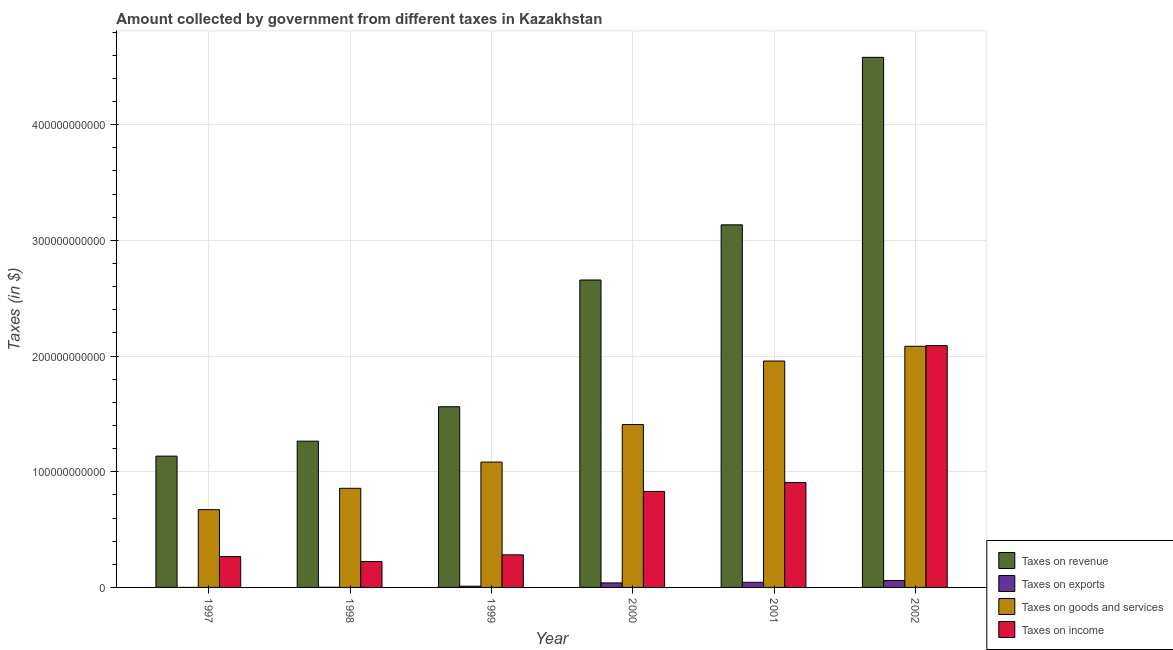How many different coloured bars are there?
Keep it short and to the point. 4. Are the number of bars per tick equal to the number of legend labels?
Ensure brevity in your answer.  Yes. How many bars are there on the 5th tick from the left?
Ensure brevity in your answer.  4. How many bars are there on the 5th tick from the right?
Your answer should be very brief. 4. What is the label of the 2nd group of bars from the left?
Ensure brevity in your answer.  1998. In how many cases, is the number of bars for a given year not equal to the number of legend labels?
Your answer should be compact. 0. What is the amount collected as tax on revenue in 1999?
Make the answer very short. 1.56e+11. Across all years, what is the maximum amount collected as tax on income?
Provide a succinct answer. 2.09e+11. Across all years, what is the minimum amount collected as tax on revenue?
Give a very brief answer. 1.13e+11. In which year was the amount collected as tax on revenue maximum?
Your response must be concise. 2002. In which year was the amount collected as tax on revenue minimum?
Provide a succinct answer. 1997. What is the total amount collected as tax on exports in the graph?
Provide a succinct answer. 1.55e+1. What is the difference between the amount collected as tax on revenue in 1997 and that in 2000?
Give a very brief answer. -1.52e+11. What is the difference between the amount collected as tax on income in 2001 and the amount collected as tax on exports in 2002?
Your answer should be very brief. -1.18e+11. What is the average amount collected as tax on income per year?
Make the answer very short. 7.66e+1. In the year 1997, what is the difference between the amount collected as tax on revenue and amount collected as tax on goods?
Keep it short and to the point. 0. In how many years, is the amount collected as tax on income greater than 300000000000 $?
Offer a very short reply. 0. What is the ratio of the amount collected as tax on goods in 1998 to that in 2000?
Provide a short and direct response. 0.61. What is the difference between the highest and the second highest amount collected as tax on revenue?
Offer a terse response. 1.45e+11. What is the difference between the highest and the lowest amount collected as tax on revenue?
Your response must be concise. 3.45e+11. Is the sum of the amount collected as tax on exports in 1998 and 2002 greater than the maximum amount collected as tax on income across all years?
Ensure brevity in your answer.  Yes. Is it the case that in every year, the sum of the amount collected as tax on exports and amount collected as tax on income is greater than the sum of amount collected as tax on goods and amount collected as tax on revenue?
Your answer should be very brief. No. What does the 1st bar from the left in 2002 represents?
Your answer should be compact. Taxes on revenue. What does the 4th bar from the right in 2002 represents?
Offer a terse response. Taxes on revenue. Is it the case that in every year, the sum of the amount collected as tax on revenue and amount collected as tax on exports is greater than the amount collected as tax on goods?
Ensure brevity in your answer.  Yes. How many bars are there?
Make the answer very short. 24. Are all the bars in the graph horizontal?
Provide a succinct answer. No. What is the difference between two consecutive major ticks on the Y-axis?
Ensure brevity in your answer.  1.00e+11. Does the graph contain any zero values?
Make the answer very short. No. Does the graph contain grids?
Give a very brief answer. Yes. Where does the legend appear in the graph?
Keep it short and to the point. Bottom right. How many legend labels are there?
Offer a very short reply. 4. What is the title of the graph?
Your answer should be very brief. Amount collected by government from different taxes in Kazakhstan. What is the label or title of the Y-axis?
Your answer should be very brief. Taxes (in $). What is the Taxes (in $) of Taxes on revenue in 1997?
Give a very brief answer. 1.13e+11. What is the Taxes (in $) in Taxes on goods and services in 1997?
Keep it short and to the point. 6.73e+1. What is the Taxes (in $) of Taxes on income in 1997?
Provide a succinct answer. 2.67e+1. What is the Taxes (in $) in Taxes on revenue in 1998?
Make the answer very short. 1.26e+11. What is the Taxes (in $) in Taxes on exports in 1998?
Give a very brief answer. 1.21e+08. What is the Taxes (in $) of Taxes on goods and services in 1998?
Your answer should be compact. 8.57e+1. What is the Taxes (in $) of Taxes on income in 1998?
Your answer should be compact. 2.24e+1. What is the Taxes (in $) of Taxes on revenue in 1999?
Provide a succinct answer. 1.56e+11. What is the Taxes (in $) in Taxes on exports in 1999?
Provide a succinct answer. 1.07e+09. What is the Taxes (in $) of Taxes on goods and services in 1999?
Your answer should be compact. 1.08e+11. What is the Taxes (in $) in Taxes on income in 1999?
Give a very brief answer. 2.82e+1. What is the Taxes (in $) of Taxes on revenue in 2000?
Give a very brief answer. 2.66e+11. What is the Taxes (in $) in Taxes on exports in 2000?
Provide a succinct answer. 3.89e+09. What is the Taxes (in $) in Taxes on goods and services in 2000?
Offer a terse response. 1.41e+11. What is the Taxes (in $) of Taxes on income in 2000?
Keep it short and to the point. 8.30e+1. What is the Taxes (in $) of Taxes on revenue in 2001?
Make the answer very short. 3.13e+11. What is the Taxes (in $) of Taxes on exports in 2001?
Make the answer very short. 4.43e+09. What is the Taxes (in $) of Taxes on goods and services in 2001?
Provide a short and direct response. 1.96e+11. What is the Taxes (in $) of Taxes on income in 2001?
Offer a terse response. 9.07e+1. What is the Taxes (in $) of Taxes on revenue in 2002?
Make the answer very short. 4.58e+11. What is the Taxes (in $) of Taxes on exports in 2002?
Your response must be concise. 5.97e+09. What is the Taxes (in $) in Taxes on goods and services in 2002?
Ensure brevity in your answer.  2.08e+11. What is the Taxes (in $) in Taxes on income in 2002?
Offer a very short reply. 2.09e+11. Across all years, what is the maximum Taxes (in $) of Taxes on revenue?
Your response must be concise. 4.58e+11. Across all years, what is the maximum Taxes (in $) in Taxes on exports?
Ensure brevity in your answer.  5.97e+09. Across all years, what is the maximum Taxes (in $) in Taxes on goods and services?
Your answer should be very brief. 2.08e+11. Across all years, what is the maximum Taxes (in $) of Taxes on income?
Your answer should be compact. 2.09e+11. Across all years, what is the minimum Taxes (in $) of Taxes on revenue?
Provide a succinct answer. 1.13e+11. Across all years, what is the minimum Taxes (in $) in Taxes on goods and services?
Offer a terse response. 6.73e+1. Across all years, what is the minimum Taxes (in $) in Taxes on income?
Ensure brevity in your answer.  2.24e+1. What is the total Taxes (in $) in Taxes on revenue in the graph?
Your answer should be very brief. 1.43e+12. What is the total Taxes (in $) of Taxes on exports in the graph?
Ensure brevity in your answer.  1.55e+1. What is the total Taxes (in $) of Taxes on goods and services in the graph?
Ensure brevity in your answer.  8.06e+11. What is the total Taxes (in $) in Taxes on income in the graph?
Provide a succinct answer. 4.60e+11. What is the difference between the Taxes (in $) in Taxes on revenue in 1997 and that in 1998?
Your response must be concise. -1.29e+1. What is the difference between the Taxes (in $) of Taxes on exports in 1997 and that in 1998?
Make the answer very short. -1.19e+08. What is the difference between the Taxes (in $) in Taxes on goods and services in 1997 and that in 1998?
Your answer should be very brief. -1.84e+1. What is the difference between the Taxes (in $) of Taxes on income in 1997 and that in 1998?
Your answer should be compact. 4.28e+09. What is the difference between the Taxes (in $) of Taxes on revenue in 1997 and that in 1999?
Keep it short and to the point. -4.27e+1. What is the difference between the Taxes (in $) of Taxes on exports in 1997 and that in 1999?
Your answer should be compact. -1.07e+09. What is the difference between the Taxes (in $) in Taxes on goods and services in 1997 and that in 1999?
Provide a short and direct response. -4.11e+1. What is the difference between the Taxes (in $) of Taxes on income in 1997 and that in 1999?
Give a very brief answer. -1.53e+09. What is the difference between the Taxes (in $) of Taxes on revenue in 1997 and that in 2000?
Offer a very short reply. -1.52e+11. What is the difference between the Taxes (in $) of Taxes on exports in 1997 and that in 2000?
Give a very brief answer. -3.88e+09. What is the difference between the Taxes (in $) of Taxes on goods and services in 1997 and that in 2000?
Keep it short and to the point. -7.35e+1. What is the difference between the Taxes (in $) of Taxes on income in 1997 and that in 2000?
Your response must be concise. -5.63e+1. What is the difference between the Taxes (in $) of Taxes on revenue in 1997 and that in 2001?
Your answer should be very brief. -2.00e+11. What is the difference between the Taxes (in $) in Taxes on exports in 1997 and that in 2001?
Your answer should be very brief. -4.43e+09. What is the difference between the Taxes (in $) of Taxes on goods and services in 1997 and that in 2001?
Keep it short and to the point. -1.28e+11. What is the difference between the Taxes (in $) in Taxes on income in 1997 and that in 2001?
Keep it short and to the point. -6.40e+1. What is the difference between the Taxes (in $) in Taxes on revenue in 1997 and that in 2002?
Offer a terse response. -3.45e+11. What is the difference between the Taxes (in $) of Taxes on exports in 1997 and that in 2002?
Provide a succinct answer. -5.96e+09. What is the difference between the Taxes (in $) of Taxes on goods and services in 1997 and that in 2002?
Make the answer very short. -1.41e+11. What is the difference between the Taxes (in $) of Taxes on income in 1997 and that in 2002?
Ensure brevity in your answer.  -1.82e+11. What is the difference between the Taxes (in $) of Taxes on revenue in 1998 and that in 1999?
Offer a terse response. -2.97e+1. What is the difference between the Taxes (in $) of Taxes on exports in 1998 and that in 1999?
Offer a terse response. -9.53e+08. What is the difference between the Taxes (in $) in Taxes on goods and services in 1998 and that in 1999?
Keep it short and to the point. -2.27e+1. What is the difference between the Taxes (in $) of Taxes on income in 1998 and that in 1999?
Keep it short and to the point. -5.81e+09. What is the difference between the Taxes (in $) of Taxes on revenue in 1998 and that in 2000?
Provide a short and direct response. -1.39e+11. What is the difference between the Taxes (in $) of Taxes on exports in 1998 and that in 2000?
Make the answer very short. -3.76e+09. What is the difference between the Taxes (in $) of Taxes on goods and services in 1998 and that in 2000?
Your answer should be very brief. -5.51e+1. What is the difference between the Taxes (in $) of Taxes on income in 1998 and that in 2000?
Offer a very short reply. -6.06e+1. What is the difference between the Taxes (in $) of Taxes on revenue in 1998 and that in 2001?
Keep it short and to the point. -1.87e+11. What is the difference between the Taxes (in $) in Taxes on exports in 1998 and that in 2001?
Make the answer very short. -4.31e+09. What is the difference between the Taxes (in $) of Taxes on goods and services in 1998 and that in 2001?
Keep it short and to the point. -1.10e+11. What is the difference between the Taxes (in $) in Taxes on income in 1998 and that in 2001?
Ensure brevity in your answer.  -6.83e+1. What is the difference between the Taxes (in $) in Taxes on revenue in 1998 and that in 2002?
Provide a succinct answer. -3.32e+11. What is the difference between the Taxes (in $) in Taxes on exports in 1998 and that in 2002?
Offer a very short reply. -5.85e+09. What is the difference between the Taxes (in $) of Taxes on goods and services in 1998 and that in 2002?
Your response must be concise. -1.23e+11. What is the difference between the Taxes (in $) in Taxes on income in 1998 and that in 2002?
Provide a short and direct response. -1.87e+11. What is the difference between the Taxes (in $) in Taxes on revenue in 1999 and that in 2000?
Offer a terse response. -1.10e+11. What is the difference between the Taxes (in $) of Taxes on exports in 1999 and that in 2000?
Your answer should be compact. -2.81e+09. What is the difference between the Taxes (in $) in Taxes on goods and services in 1999 and that in 2000?
Offer a terse response. -3.24e+1. What is the difference between the Taxes (in $) in Taxes on income in 1999 and that in 2000?
Provide a succinct answer. -5.48e+1. What is the difference between the Taxes (in $) of Taxes on revenue in 1999 and that in 2001?
Make the answer very short. -1.57e+11. What is the difference between the Taxes (in $) in Taxes on exports in 1999 and that in 2001?
Your answer should be very brief. -3.36e+09. What is the difference between the Taxes (in $) in Taxes on goods and services in 1999 and that in 2001?
Your response must be concise. -8.74e+1. What is the difference between the Taxes (in $) of Taxes on income in 1999 and that in 2001?
Provide a short and direct response. -6.25e+1. What is the difference between the Taxes (in $) of Taxes on revenue in 1999 and that in 2002?
Your response must be concise. -3.02e+11. What is the difference between the Taxes (in $) in Taxes on exports in 1999 and that in 2002?
Ensure brevity in your answer.  -4.89e+09. What is the difference between the Taxes (in $) of Taxes on goods and services in 1999 and that in 2002?
Make the answer very short. -1.00e+11. What is the difference between the Taxes (in $) of Taxes on income in 1999 and that in 2002?
Keep it short and to the point. -1.81e+11. What is the difference between the Taxes (in $) of Taxes on revenue in 2000 and that in 2001?
Offer a very short reply. -4.77e+1. What is the difference between the Taxes (in $) of Taxes on exports in 2000 and that in 2001?
Your response must be concise. -5.48e+08. What is the difference between the Taxes (in $) in Taxes on goods and services in 2000 and that in 2001?
Provide a short and direct response. -5.49e+1. What is the difference between the Taxes (in $) of Taxes on income in 2000 and that in 2001?
Provide a short and direct response. -7.72e+09. What is the difference between the Taxes (in $) in Taxes on revenue in 2000 and that in 2002?
Keep it short and to the point. -1.92e+11. What is the difference between the Taxes (in $) of Taxes on exports in 2000 and that in 2002?
Make the answer very short. -2.08e+09. What is the difference between the Taxes (in $) in Taxes on goods and services in 2000 and that in 2002?
Offer a very short reply. -6.77e+1. What is the difference between the Taxes (in $) in Taxes on income in 2000 and that in 2002?
Your answer should be very brief. -1.26e+11. What is the difference between the Taxes (in $) in Taxes on revenue in 2001 and that in 2002?
Provide a succinct answer. -1.45e+11. What is the difference between the Taxes (in $) of Taxes on exports in 2001 and that in 2002?
Offer a very short reply. -1.53e+09. What is the difference between the Taxes (in $) in Taxes on goods and services in 2001 and that in 2002?
Ensure brevity in your answer.  -1.27e+1. What is the difference between the Taxes (in $) in Taxes on income in 2001 and that in 2002?
Ensure brevity in your answer.  -1.18e+11. What is the difference between the Taxes (in $) in Taxes on revenue in 1997 and the Taxes (in $) in Taxes on exports in 1998?
Offer a very short reply. 1.13e+11. What is the difference between the Taxes (in $) in Taxes on revenue in 1997 and the Taxes (in $) in Taxes on goods and services in 1998?
Provide a succinct answer. 2.78e+1. What is the difference between the Taxes (in $) of Taxes on revenue in 1997 and the Taxes (in $) of Taxes on income in 1998?
Ensure brevity in your answer.  9.11e+1. What is the difference between the Taxes (in $) of Taxes on exports in 1997 and the Taxes (in $) of Taxes on goods and services in 1998?
Provide a short and direct response. -8.57e+1. What is the difference between the Taxes (in $) of Taxes on exports in 1997 and the Taxes (in $) of Taxes on income in 1998?
Keep it short and to the point. -2.24e+1. What is the difference between the Taxes (in $) in Taxes on goods and services in 1997 and the Taxes (in $) in Taxes on income in 1998?
Your answer should be compact. 4.49e+1. What is the difference between the Taxes (in $) in Taxes on revenue in 1997 and the Taxes (in $) in Taxes on exports in 1999?
Your answer should be compact. 1.12e+11. What is the difference between the Taxes (in $) in Taxes on revenue in 1997 and the Taxes (in $) in Taxes on goods and services in 1999?
Your response must be concise. 5.15e+09. What is the difference between the Taxes (in $) in Taxes on revenue in 1997 and the Taxes (in $) in Taxes on income in 1999?
Keep it short and to the point. 8.53e+1. What is the difference between the Taxes (in $) of Taxes on exports in 1997 and the Taxes (in $) of Taxes on goods and services in 1999?
Provide a short and direct response. -1.08e+11. What is the difference between the Taxes (in $) in Taxes on exports in 1997 and the Taxes (in $) in Taxes on income in 1999?
Ensure brevity in your answer.  -2.82e+1. What is the difference between the Taxes (in $) of Taxes on goods and services in 1997 and the Taxes (in $) of Taxes on income in 1999?
Your response must be concise. 3.91e+1. What is the difference between the Taxes (in $) in Taxes on revenue in 1997 and the Taxes (in $) in Taxes on exports in 2000?
Offer a very short reply. 1.10e+11. What is the difference between the Taxes (in $) in Taxes on revenue in 1997 and the Taxes (in $) in Taxes on goods and services in 2000?
Your response must be concise. -2.73e+1. What is the difference between the Taxes (in $) in Taxes on revenue in 1997 and the Taxes (in $) in Taxes on income in 2000?
Provide a short and direct response. 3.05e+1. What is the difference between the Taxes (in $) in Taxes on exports in 1997 and the Taxes (in $) in Taxes on goods and services in 2000?
Keep it short and to the point. -1.41e+11. What is the difference between the Taxes (in $) in Taxes on exports in 1997 and the Taxes (in $) in Taxes on income in 2000?
Ensure brevity in your answer.  -8.30e+1. What is the difference between the Taxes (in $) in Taxes on goods and services in 1997 and the Taxes (in $) in Taxes on income in 2000?
Your answer should be compact. -1.57e+1. What is the difference between the Taxes (in $) in Taxes on revenue in 1997 and the Taxes (in $) in Taxes on exports in 2001?
Keep it short and to the point. 1.09e+11. What is the difference between the Taxes (in $) of Taxes on revenue in 1997 and the Taxes (in $) of Taxes on goods and services in 2001?
Your response must be concise. -8.22e+1. What is the difference between the Taxes (in $) in Taxes on revenue in 1997 and the Taxes (in $) in Taxes on income in 2001?
Your answer should be compact. 2.28e+1. What is the difference between the Taxes (in $) of Taxes on exports in 1997 and the Taxes (in $) of Taxes on goods and services in 2001?
Ensure brevity in your answer.  -1.96e+11. What is the difference between the Taxes (in $) in Taxes on exports in 1997 and the Taxes (in $) in Taxes on income in 2001?
Give a very brief answer. -9.07e+1. What is the difference between the Taxes (in $) in Taxes on goods and services in 1997 and the Taxes (in $) in Taxes on income in 2001?
Your response must be concise. -2.34e+1. What is the difference between the Taxes (in $) in Taxes on revenue in 1997 and the Taxes (in $) in Taxes on exports in 2002?
Your answer should be very brief. 1.08e+11. What is the difference between the Taxes (in $) of Taxes on revenue in 1997 and the Taxes (in $) of Taxes on goods and services in 2002?
Make the answer very short. -9.50e+1. What is the difference between the Taxes (in $) in Taxes on revenue in 1997 and the Taxes (in $) in Taxes on income in 2002?
Offer a terse response. -9.56e+1. What is the difference between the Taxes (in $) of Taxes on exports in 1997 and the Taxes (in $) of Taxes on goods and services in 2002?
Keep it short and to the point. -2.08e+11. What is the difference between the Taxes (in $) in Taxes on exports in 1997 and the Taxes (in $) in Taxes on income in 2002?
Offer a very short reply. -2.09e+11. What is the difference between the Taxes (in $) of Taxes on goods and services in 1997 and the Taxes (in $) of Taxes on income in 2002?
Offer a very short reply. -1.42e+11. What is the difference between the Taxes (in $) in Taxes on revenue in 1998 and the Taxes (in $) in Taxes on exports in 1999?
Offer a very short reply. 1.25e+11. What is the difference between the Taxes (in $) of Taxes on revenue in 1998 and the Taxes (in $) of Taxes on goods and services in 1999?
Provide a succinct answer. 1.81e+1. What is the difference between the Taxes (in $) of Taxes on revenue in 1998 and the Taxes (in $) of Taxes on income in 1999?
Give a very brief answer. 9.83e+1. What is the difference between the Taxes (in $) in Taxes on exports in 1998 and the Taxes (in $) in Taxes on goods and services in 1999?
Make the answer very short. -1.08e+11. What is the difference between the Taxes (in $) in Taxes on exports in 1998 and the Taxes (in $) in Taxes on income in 1999?
Give a very brief answer. -2.81e+1. What is the difference between the Taxes (in $) of Taxes on goods and services in 1998 and the Taxes (in $) of Taxes on income in 1999?
Provide a short and direct response. 5.75e+1. What is the difference between the Taxes (in $) in Taxes on revenue in 1998 and the Taxes (in $) in Taxes on exports in 2000?
Make the answer very short. 1.23e+11. What is the difference between the Taxes (in $) of Taxes on revenue in 1998 and the Taxes (in $) of Taxes on goods and services in 2000?
Make the answer very short. -1.43e+1. What is the difference between the Taxes (in $) of Taxes on revenue in 1998 and the Taxes (in $) of Taxes on income in 2000?
Your answer should be compact. 4.35e+1. What is the difference between the Taxes (in $) in Taxes on exports in 1998 and the Taxes (in $) in Taxes on goods and services in 2000?
Keep it short and to the point. -1.41e+11. What is the difference between the Taxes (in $) in Taxes on exports in 1998 and the Taxes (in $) in Taxes on income in 2000?
Your answer should be compact. -8.28e+1. What is the difference between the Taxes (in $) in Taxes on goods and services in 1998 and the Taxes (in $) in Taxes on income in 2000?
Your response must be concise. 2.72e+09. What is the difference between the Taxes (in $) of Taxes on revenue in 1998 and the Taxes (in $) of Taxes on exports in 2001?
Give a very brief answer. 1.22e+11. What is the difference between the Taxes (in $) of Taxes on revenue in 1998 and the Taxes (in $) of Taxes on goods and services in 2001?
Your answer should be compact. -6.93e+1. What is the difference between the Taxes (in $) in Taxes on revenue in 1998 and the Taxes (in $) in Taxes on income in 2001?
Your answer should be compact. 3.58e+1. What is the difference between the Taxes (in $) in Taxes on exports in 1998 and the Taxes (in $) in Taxes on goods and services in 2001?
Provide a short and direct response. -1.96e+11. What is the difference between the Taxes (in $) of Taxes on exports in 1998 and the Taxes (in $) of Taxes on income in 2001?
Offer a very short reply. -9.06e+1. What is the difference between the Taxes (in $) in Taxes on goods and services in 1998 and the Taxes (in $) in Taxes on income in 2001?
Provide a succinct answer. -4.99e+09. What is the difference between the Taxes (in $) of Taxes on revenue in 1998 and the Taxes (in $) of Taxes on exports in 2002?
Offer a terse response. 1.20e+11. What is the difference between the Taxes (in $) in Taxes on revenue in 1998 and the Taxes (in $) in Taxes on goods and services in 2002?
Give a very brief answer. -8.20e+1. What is the difference between the Taxes (in $) of Taxes on revenue in 1998 and the Taxes (in $) of Taxes on income in 2002?
Your answer should be compact. -8.26e+1. What is the difference between the Taxes (in $) in Taxes on exports in 1998 and the Taxes (in $) in Taxes on goods and services in 2002?
Provide a succinct answer. -2.08e+11. What is the difference between the Taxes (in $) of Taxes on exports in 1998 and the Taxes (in $) of Taxes on income in 2002?
Provide a succinct answer. -2.09e+11. What is the difference between the Taxes (in $) in Taxes on goods and services in 1998 and the Taxes (in $) in Taxes on income in 2002?
Your response must be concise. -1.23e+11. What is the difference between the Taxes (in $) in Taxes on revenue in 1999 and the Taxes (in $) in Taxes on exports in 2000?
Provide a succinct answer. 1.52e+11. What is the difference between the Taxes (in $) in Taxes on revenue in 1999 and the Taxes (in $) in Taxes on goods and services in 2000?
Offer a very short reply. 1.54e+1. What is the difference between the Taxes (in $) of Taxes on revenue in 1999 and the Taxes (in $) of Taxes on income in 2000?
Your response must be concise. 7.32e+1. What is the difference between the Taxes (in $) of Taxes on exports in 1999 and the Taxes (in $) of Taxes on goods and services in 2000?
Your answer should be very brief. -1.40e+11. What is the difference between the Taxes (in $) of Taxes on exports in 1999 and the Taxes (in $) of Taxes on income in 2000?
Provide a short and direct response. -8.19e+1. What is the difference between the Taxes (in $) of Taxes on goods and services in 1999 and the Taxes (in $) of Taxes on income in 2000?
Offer a very short reply. 2.54e+1. What is the difference between the Taxes (in $) of Taxes on revenue in 1999 and the Taxes (in $) of Taxes on exports in 2001?
Your response must be concise. 1.52e+11. What is the difference between the Taxes (in $) of Taxes on revenue in 1999 and the Taxes (in $) of Taxes on goods and services in 2001?
Your answer should be compact. -3.95e+1. What is the difference between the Taxes (in $) of Taxes on revenue in 1999 and the Taxes (in $) of Taxes on income in 2001?
Give a very brief answer. 6.55e+1. What is the difference between the Taxes (in $) of Taxes on exports in 1999 and the Taxes (in $) of Taxes on goods and services in 2001?
Keep it short and to the point. -1.95e+11. What is the difference between the Taxes (in $) in Taxes on exports in 1999 and the Taxes (in $) in Taxes on income in 2001?
Your answer should be very brief. -8.96e+1. What is the difference between the Taxes (in $) of Taxes on goods and services in 1999 and the Taxes (in $) of Taxes on income in 2001?
Keep it short and to the point. 1.77e+1. What is the difference between the Taxes (in $) of Taxes on revenue in 1999 and the Taxes (in $) of Taxes on exports in 2002?
Make the answer very short. 1.50e+11. What is the difference between the Taxes (in $) of Taxes on revenue in 1999 and the Taxes (in $) of Taxes on goods and services in 2002?
Provide a short and direct response. -5.23e+1. What is the difference between the Taxes (in $) of Taxes on revenue in 1999 and the Taxes (in $) of Taxes on income in 2002?
Offer a terse response. -5.29e+1. What is the difference between the Taxes (in $) of Taxes on exports in 1999 and the Taxes (in $) of Taxes on goods and services in 2002?
Keep it short and to the point. -2.07e+11. What is the difference between the Taxes (in $) of Taxes on exports in 1999 and the Taxes (in $) of Taxes on income in 2002?
Offer a very short reply. -2.08e+11. What is the difference between the Taxes (in $) in Taxes on goods and services in 1999 and the Taxes (in $) in Taxes on income in 2002?
Offer a terse response. -1.01e+11. What is the difference between the Taxes (in $) of Taxes on revenue in 2000 and the Taxes (in $) of Taxes on exports in 2001?
Your response must be concise. 2.61e+11. What is the difference between the Taxes (in $) of Taxes on revenue in 2000 and the Taxes (in $) of Taxes on goods and services in 2001?
Make the answer very short. 7.00e+1. What is the difference between the Taxes (in $) in Taxes on revenue in 2000 and the Taxes (in $) in Taxes on income in 2001?
Ensure brevity in your answer.  1.75e+11. What is the difference between the Taxes (in $) of Taxes on exports in 2000 and the Taxes (in $) of Taxes on goods and services in 2001?
Offer a terse response. -1.92e+11. What is the difference between the Taxes (in $) of Taxes on exports in 2000 and the Taxes (in $) of Taxes on income in 2001?
Offer a terse response. -8.68e+1. What is the difference between the Taxes (in $) in Taxes on goods and services in 2000 and the Taxes (in $) in Taxes on income in 2001?
Offer a terse response. 5.01e+1. What is the difference between the Taxes (in $) in Taxes on revenue in 2000 and the Taxes (in $) in Taxes on exports in 2002?
Provide a succinct answer. 2.60e+11. What is the difference between the Taxes (in $) of Taxes on revenue in 2000 and the Taxes (in $) of Taxes on goods and services in 2002?
Offer a terse response. 5.73e+1. What is the difference between the Taxes (in $) in Taxes on revenue in 2000 and the Taxes (in $) in Taxes on income in 2002?
Provide a short and direct response. 5.67e+1. What is the difference between the Taxes (in $) in Taxes on exports in 2000 and the Taxes (in $) in Taxes on goods and services in 2002?
Ensure brevity in your answer.  -2.05e+11. What is the difference between the Taxes (in $) in Taxes on exports in 2000 and the Taxes (in $) in Taxes on income in 2002?
Your answer should be compact. -2.05e+11. What is the difference between the Taxes (in $) in Taxes on goods and services in 2000 and the Taxes (in $) in Taxes on income in 2002?
Provide a short and direct response. -6.83e+1. What is the difference between the Taxes (in $) of Taxes on revenue in 2001 and the Taxes (in $) of Taxes on exports in 2002?
Provide a short and direct response. 3.07e+11. What is the difference between the Taxes (in $) in Taxes on revenue in 2001 and the Taxes (in $) in Taxes on goods and services in 2002?
Keep it short and to the point. 1.05e+11. What is the difference between the Taxes (in $) of Taxes on revenue in 2001 and the Taxes (in $) of Taxes on income in 2002?
Your answer should be very brief. 1.04e+11. What is the difference between the Taxes (in $) of Taxes on exports in 2001 and the Taxes (in $) of Taxes on goods and services in 2002?
Offer a very short reply. -2.04e+11. What is the difference between the Taxes (in $) of Taxes on exports in 2001 and the Taxes (in $) of Taxes on income in 2002?
Give a very brief answer. -2.05e+11. What is the difference between the Taxes (in $) of Taxes on goods and services in 2001 and the Taxes (in $) of Taxes on income in 2002?
Offer a very short reply. -1.33e+1. What is the average Taxes (in $) of Taxes on revenue per year?
Ensure brevity in your answer.  2.39e+11. What is the average Taxes (in $) of Taxes on exports per year?
Your response must be concise. 2.58e+09. What is the average Taxes (in $) of Taxes on goods and services per year?
Provide a short and direct response. 1.34e+11. What is the average Taxes (in $) in Taxes on income per year?
Make the answer very short. 7.66e+1. In the year 1997, what is the difference between the Taxes (in $) in Taxes on revenue and Taxes (in $) in Taxes on exports?
Your answer should be very brief. 1.13e+11. In the year 1997, what is the difference between the Taxes (in $) in Taxes on revenue and Taxes (in $) in Taxes on goods and services?
Provide a succinct answer. 4.62e+1. In the year 1997, what is the difference between the Taxes (in $) in Taxes on revenue and Taxes (in $) in Taxes on income?
Provide a succinct answer. 8.68e+1. In the year 1997, what is the difference between the Taxes (in $) of Taxes on exports and Taxes (in $) of Taxes on goods and services?
Your answer should be very brief. -6.72e+1. In the year 1997, what is the difference between the Taxes (in $) in Taxes on exports and Taxes (in $) in Taxes on income?
Your answer should be very brief. -2.66e+1. In the year 1997, what is the difference between the Taxes (in $) of Taxes on goods and services and Taxes (in $) of Taxes on income?
Your answer should be very brief. 4.06e+1. In the year 1998, what is the difference between the Taxes (in $) of Taxes on revenue and Taxes (in $) of Taxes on exports?
Keep it short and to the point. 1.26e+11. In the year 1998, what is the difference between the Taxes (in $) of Taxes on revenue and Taxes (in $) of Taxes on goods and services?
Provide a succinct answer. 4.08e+1. In the year 1998, what is the difference between the Taxes (in $) of Taxes on revenue and Taxes (in $) of Taxes on income?
Your answer should be compact. 1.04e+11. In the year 1998, what is the difference between the Taxes (in $) in Taxes on exports and Taxes (in $) in Taxes on goods and services?
Ensure brevity in your answer.  -8.56e+1. In the year 1998, what is the difference between the Taxes (in $) in Taxes on exports and Taxes (in $) in Taxes on income?
Provide a succinct answer. -2.22e+1. In the year 1998, what is the difference between the Taxes (in $) in Taxes on goods and services and Taxes (in $) in Taxes on income?
Your answer should be very brief. 6.33e+1. In the year 1999, what is the difference between the Taxes (in $) in Taxes on revenue and Taxes (in $) in Taxes on exports?
Make the answer very short. 1.55e+11. In the year 1999, what is the difference between the Taxes (in $) of Taxes on revenue and Taxes (in $) of Taxes on goods and services?
Your answer should be compact. 4.78e+1. In the year 1999, what is the difference between the Taxes (in $) in Taxes on revenue and Taxes (in $) in Taxes on income?
Provide a short and direct response. 1.28e+11. In the year 1999, what is the difference between the Taxes (in $) in Taxes on exports and Taxes (in $) in Taxes on goods and services?
Keep it short and to the point. -1.07e+11. In the year 1999, what is the difference between the Taxes (in $) in Taxes on exports and Taxes (in $) in Taxes on income?
Provide a succinct answer. -2.71e+1. In the year 1999, what is the difference between the Taxes (in $) of Taxes on goods and services and Taxes (in $) of Taxes on income?
Offer a terse response. 8.02e+1. In the year 2000, what is the difference between the Taxes (in $) of Taxes on revenue and Taxes (in $) of Taxes on exports?
Offer a very short reply. 2.62e+11. In the year 2000, what is the difference between the Taxes (in $) in Taxes on revenue and Taxes (in $) in Taxes on goods and services?
Your answer should be very brief. 1.25e+11. In the year 2000, what is the difference between the Taxes (in $) in Taxes on revenue and Taxes (in $) in Taxes on income?
Your answer should be very brief. 1.83e+11. In the year 2000, what is the difference between the Taxes (in $) in Taxes on exports and Taxes (in $) in Taxes on goods and services?
Ensure brevity in your answer.  -1.37e+11. In the year 2000, what is the difference between the Taxes (in $) of Taxes on exports and Taxes (in $) of Taxes on income?
Offer a terse response. -7.91e+1. In the year 2000, what is the difference between the Taxes (in $) in Taxes on goods and services and Taxes (in $) in Taxes on income?
Your response must be concise. 5.78e+1. In the year 2001, what is the difference between the Taxes (in $) of Taxes on revenue and Taxes (in $) of Taxes on exports?
Give a very brief answer. 3.09e+11. In the year 2001, what is the difference between the Taxes (in $) in Taxes on revenue and Taxes (in $) in Taxes on goods and services?
Make the answer very short. 1.18e+11. In the year 2001, what is the difference between the Taxes (in $) of Taxes on revenue and Taxes (in $) of Taxes on income?
Offer a very short reply. 2.23e+11. In the year 2001, what is the difference between the Taxes (in $) of Taxes on exports and Taxes (in $) of Taxes on goods and services?
Your answer should be very brief. -1.91e+11. In the year 2001, what is the difference between the Taxes (in $) of Taxes on exports and Taxes (in $) of Taxes on income?
Offer a terse response. -8.62e+1. In the year 2001, what is the difference between the Taxes (in $) of Taxes on goods and services and Taxes (in $) of Taxes on income?
Provide a succinct answer. 1.05e+11. In the year 2002, what is the difference between the Taxes (in $) in Taxes on revenue and Taxes (in $) in Taxes on exports?
Your answer should be very brief. 4.52e+11. In the year 2002, what is the difference between the Taxes (in $) in Taxes on revenue and Taxes (in $) in Taxes on goods and services?
Provide a succinct answer. 2.50e+11. In the year 2002, what is the difference between the Taxes (in $) of Taxes on revenue and Taxes (in $) of Taxes on income?
Give a very brief answer. 2.49e+11. In the year 2002, what is the difference between the Taxes (in $) of Taxes on exports and Taxes (in $) of Taxes on goods and services?
Offer a terse response. -2.02e+11. In the year 2002, what is the difference between the Taxes (in $) in Taxes on exports and Taxes (in $) in Taxes on income?
Offer a terse response. -2.03e+11. In the year 2002, what is the difference between the Taxes (in $) of Taxes on goods and services and Taxes (in $) of Taxes on income?
Provide a succinct answer. -6.00e+08. What is the ratio of the Taxes (in $) in Taxes on revenue in 1997 to that in 1998?
Provide a succinct answer. 0.9. What is the ratio of the Taxes (in $) of Taxes on exports in 1997 to that in 1998?
Offer a terse response. 0.02. What is the ratio of the Taxes (in $) of Taxes on goods and services in 1997 to that in 1998?
Offer a terse response. 0.78. What is the ratio of the Taxes (in $) in Taxes on income in 1997 to that in 1998?
Provide a short and direct response. 1.19. What is the ratio of the Taxes (in $) of Taxes on revenue in 1997 to that in 1999?
Give a very brief answer. 0.73. What is the ratio of the Taxes (in $) in Taxes on exports in 1997 to that in 1999?
Provide a succinct answer. 0. What is the ratio of the Taxes (in $) of Taxes on goods and services in 1997 to that in 1999?
Give a very brief answer. 0.62. What is the ratio of the Taxes (in $) in Taxes on income in 1997 to that in 1999?
Keep it short and to the point. 0.95. What is the ratio of the Taxes (in $) of Taxes on revenue in 1997 to that in 2000?
Your response must be concise. 0.43. What is the ratio of the Taxes (in $) of Taxes on exports in 1997 to that in 2000?
Make the answer very short. 0. What is the ratio of the Taxes (in $) in Taxes on goods and services in 1997 to that in 2000?
Keep it short and to the point. 0.48. What is the ratio of the Taxes (in $) in Taxes on income in 1997 to that in 2000?
Provide a short and direct response. 0.32. What is the ratio of the Taxes (in $) in Taxes on revenue in 1997 to that in 2001?
Provide a short and direct response. 0.36. What is the ratio of the Taxes (in $) of Taxes on exports in 1997 to that in 2001?
Provide a short and direct response. 0. What is the ratio of the Taxes (in $) of Taxes on goods and services in 1997 to that in 2001?
Ensure brevity in your answer.  0.34. What is the ratio of the Taxes (in $) of Taxes on income in 1997 to that in 2001?
Offer a terse response. 0.29. What is the ratio of the Taxes (in $) in Taxes on revenue in 1997 to that in 2002?
Your answer should be very brief. 0.25. What is the ratio of the Taxes (in $) of Taxes on goods and services in 1997 to that in 2002?
Provide a short and direct response. 0.32. What is the ratio of the Taxes (in $) of Taxes on income in 1997 to that in 2002?
Offer a very short reply. 0.13. What is the ratio of the Taxes (in $) of Taxes on revenue in 1998 to that in 1999?
Provide a succinct answer. 0.81. What is the ratio of the Taxes (in $) of Taxes on exports in 1998 to that in 1999?
Offer a terse response. 0.11. What is the ratio of the Taxes (in $) in Taxes on goods and services in 1998 to that in 1999?
Ensure brevity in your answer.  0.79. What is the ratio of the Taxes (in $) in Taxes on income in 1998 to that in 1999?
Provide a short and direct response. 0.79. What is the ratio of the Taxes (in $) of Taxes on revenue in 1998 to that in 2000?
Give a very brief answer. 0.48. What is the ratio of the Taxes (in $) of Taxes on exports in 1998 to that in 2000?
Offer a terse response. 0.03. What is the ratio of the Taxes (in $) of Taxes on goods and services in 1998 to that in 2000?
Provide a succinct answer. 0.61. What is the ratio of the Taxes (in $) of Taxes on income in 1998 to that in 2000?
Offer a very short reply. 0.27. What is the ratio of the Taxes (in $) in Taxes on revenue in 1998 to that in 2001?
Ensure brevity in your answer.  0.4. What is the ratio of the Taxes (in $) of Taxes on exports in 1998 to that in 2001?
Keep it short and to the point. 0.03. What is the ratio of the Taxes (in $) of Taxes on goods and services in 1998 to that in 2001?
Give a very brief answer. 0.44. What is the ratio of the Taxes (in $) in Taxes on income in 1998 to that in 2001?
Offer a terse response. 0.25. What is the ratio of the Taxes (in $) of Taxes on revenue in 1998 to that in 2002?
Keep it short and to the point. 0.28. What is the ratio of the Taxes (in $) of Taxes on exports in 1998 to that in 2002?
Offer a very short reply. 0.02. What is the ratio of the Taxes (in $) of Taxes on goods and services in 1998 to that in 2002?
Give a very brief answer. 0.41. What is the ratio of the Taxes (in $) of Taxes on income in 1998 to that in 2002?
Your answer should be compact. 0.11. What is the ratio of the Taxes (in $) of Taxes on revenue in 1999 to that in 2000?
Offer a terse response. 0.59. What is the ratio of the Taxes (in $) of Taxes on exports in 1999 to that in 2000?
Ensure brevity in your answer.  0.28. What is the ratio of the Taxes (in $) of Taxes on goods and services in 1999 to that in 2000?
Your answer should be compact. 0.77. What is the ratio of the Taxes (in $) of Taxes on income in 1999 to that in 2000?
Your answer should be compact. 0.34. What is the ratio of the Taxes (in $) in Taxes on revenue in 1999 to that in 2001?
Your answer should be compact. 0.5. What is the ratio of the Taxes (in $) of Taxes on exports in 1999 to that in 2001?
Ensure brevity in your answer.  0.24. What is the ratio of the Taxes (in $) in Taxes on goods and services in 1999 to that in 2001?
Your response must be concise. 0.55. What is the ratio of the Taxes (in $) in Taxes on income in 1999 to that in 2001?
Make the answer very short. 0.31. What is the ratio of the Taxes (in $) in Taxes on revenue in 1999 to that in 2002?
Keep it short and to the point. 0.34. What is the ratio of the Taxes (in $) of Taxes on exports in 1999 to that in 2002?
Your answer should be very brief. 0.18. What is the ratio of the Taxes (in $) in Taxes on goods and services in 1999 to that in 2002?
Ensure brevity in your answer.  0.52. What is the ratio of the Taxes (in $) in Taxes on income in 1999 to that in 2002?
Your answer should be very brief. 0.13. What is the ratio of the Taxes (in $) of Taxes on revenue in 2000 to that in 2001?
Offer a very short reply. 0.85. What is the ratio of the Taxes (in $) of Taxes on exports in 2000 to that in 2001?
Provide a short and direct response. 0.88. What is the ratio of the Taxes (in $) in Taxes on goods and services in 2000 to that in 2001?
Your response must be concise. 0.72. What is the ratio of the Taxes (in $) of Taxes on income in 2000 to that in 2001?
Keep it short and to the point. 0.91. What is the ratio of the Taxes (in $) in Taxes on revenue in 2000 to that in 2002?
Ensure brevity in your answer.  0.58. What is the ratio of the Taxes (in $) in Taxes on exports in 2000 to that in 2002?
Your answer should be compact. 0.65. What is the ratio of the Taxes (in $) of Taxes on goods and services in 2000 to that in 2002?
Your response must be concise. 0.68. What is the ratio of the Taxes (in $) of Taxes on income in 2000 to that in 2002?
Provide a short and direct response. 0.4. What is the ratio of the Taxes (in $) in Taxes on revenue in 2001 to that in 2002?
Your response must be concise. 0.68. What is the ratio of the Taxes (in $) of Taxes on exports in 2001 to that in 2002?
Offer a terse response. 0.74. What is the ratio of the Taxes (in $) of Taxes on goods and services in 2001 to that in 2002?
Ensure brevity in your answer.  0.94. What is the ratio of the Taxes (in $) in Taxes on income in 2001 to that in 2002?
Your response must be concise. 0.43. What is the difference between the highest and the second highest Taxes (in $) of Taxes on revenue?
Provide a short and direct response. 1.45e+11. What is the difference between the highest and the second highest Taxes (in $) in Taxes on exports?
Offer a very short reply. 1.53e+09. What is the difference between the highest and the second highest Taxes (in $) in Taxes on goods and services?
Keep it short and to the point. 1.27e+1. What is the difference between the highest and the second highest Taxes (in $) of Taxes on income?
Your answer should be compact. 1.18e+11. What is the difference between the highest and the lowest Taxes (in $) of Taxes on revenue?
Give a very brief answer. 3.45e+11. What is the difference between the highest and the lowest Taxes (in $) of Taxes on exports?
Make the answer very short. 5.96e+09. What is the difference between the highest and the lowest Taxes (in $) of Taxes on goods and services?
Your answer should be very brief. 1.41e+11. What is the difference between the highest and the lowest Taxes (in $) in Taxes on income?
Offer a terse response. 1.87e+11. 